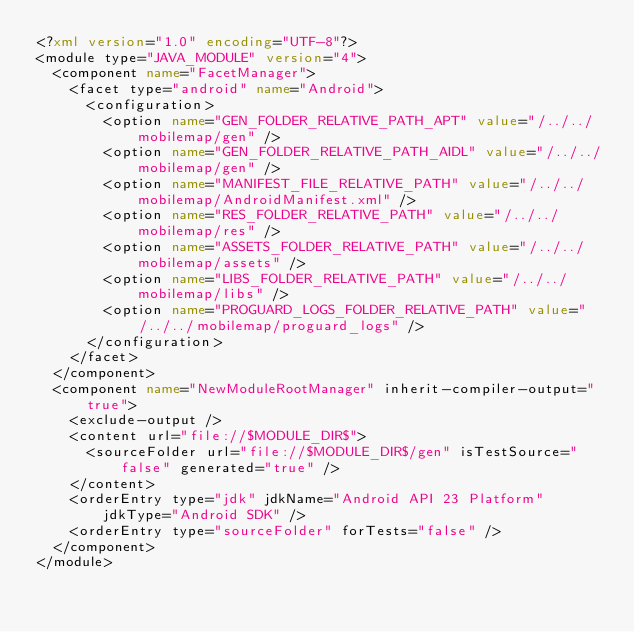Convert code to text. <code><loc_0><loc_0><loc_500><loc_500><_XML_><?xml version="1.0" encoding="UTF-8"?>
<module type="JAVA_MODULE" version="4">
  <component name="FacetManager">
    <facet type="android" name="Android">
      <configuration>
        <option name="GEN_FOLDER_RELATIVE_PATH_APT" value="/../../mobilemap/gen" />
        <option name="GEN_FOLDER_RELATIVE_PATH_AIDL" value="/../../mobilemap/gen" />
        <option name="MANIFEST_FILE_RELATIVE_PATH" value="/../../mobilemap/AndroidManifest.xml" />
        <option name="RES_FOLDER_RELATIVE_PATH" value="/../../mobilemap/res" />
        <option name="ASSETS_FOLDER_RELATIVE_PATH" value="/../../mobilemap/assets" />
        <option name="LIBS_FOLDER_RELATIVE_PATH" value="/../../mobilemap/libs" />
        <option name="PROGUARD_LOGS_FOLDER_RELATIVE_PATH" value="/../../mobilemap/proguard_logs" />
      </configuration>
    </facet>
  </component>
  <component name="NewModuleRootManager" inherit-compiler-output="true">
    <exclude-output />
    <content url="file://$MODULE_DIR$">
      <sourceFolder url="file://$MODULE_DIR$/gen" isTestSource="false" generated="true" />
    </content>
    <orderEntry type="jdk" jdkName="Android API 23 Platform" jdkType="Android SDK" />
    <orderEntry type="sourceFolder" forTests="false" />
  </component>
</module></code> 